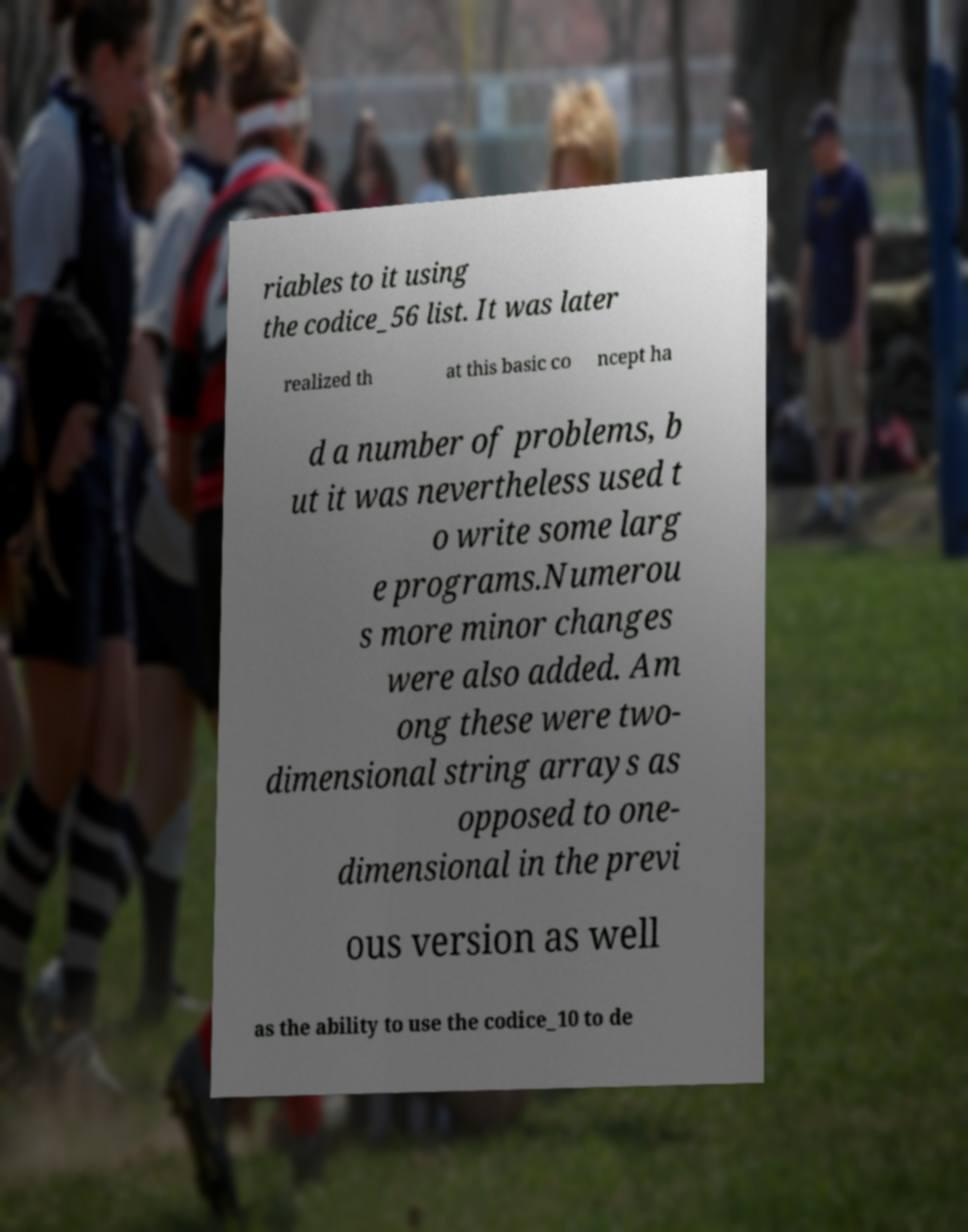Please identify and transcribe the text found in this image. riables to it using the codice_56 list. It was later realized th at this basic co ncept ha d a number of problems, b ut it was nevertheless used t o write some larg e programs.Numerou s more minor changes were also added. Am ong these were two- dimensional string arrays as opposed to one- dimensional in the previ ous version as well as the ability to use the codice_10 to de 